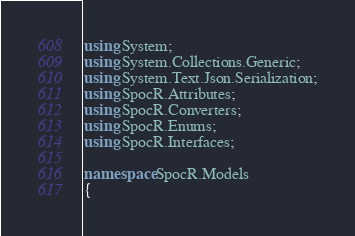<code> <loc_0><loc_0><loc_500><loc_500><_C#_>using System;
using System.Collections.Generic;
using System.Text.Json.Serialization;
using SpocR.Attributes;
using SpocR.Converters;
using SpocR.Enums;
using SpocR.Interfaces;

namespace SpocR.Models
{</code> 